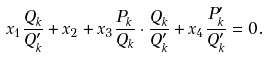Convert formula to latex. <formula><loc_0><loc_0><loc_500><loc_500>x _ { 1 } \frac { Q _ { k } } { Q ^ { \prime } _ { k } } + x _ { 2 } + x _ { 3 } \frac { P _ { k } } { Q _ { k } } \cdot \frac { Q _ { k } } { Q ^ { \prime } _ { k } } + x _ { 4 } \frac { P ^ { \prime } _ { k } } { Q ^ { \prime } _ { k } } = 0 .</formula> 